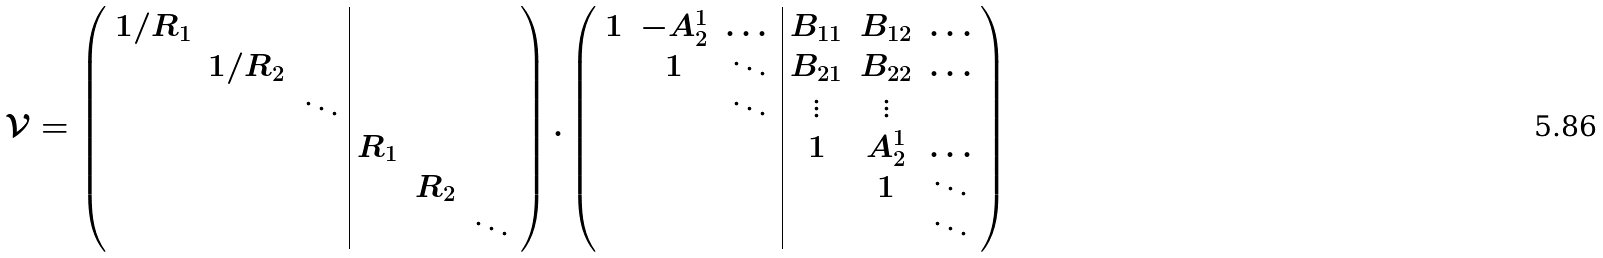Convert formula to latex. <formula><loc_0><loc_0><loc_500><loc_500>\mathcal { V } = \left ( \begin{array} { c c c | c c c } 1 / R _ { 1 } & & & & & \\ & 1 / R _ { 2 } & & & & \\ & & \ddots & & & \\ & & & R _ { 1 } & & \\ & & & & R _ { 2 } & \\ & & & & & \ddots \end{array} \right ) . \left ( \begin{array} { c c c | c c c } 1 & - A _ { 2 } ^ { 1 } & \dots & B _ { 1 1 } & B _ { 1 2 } & \dots \\ & 1 & \ddots & B _ { 2 1 } & B _ { 2 2 } & \dots \\ & & \ddots & \vdots & \vdots & \\ & & & 1 & A _ { 2 } ^ { 1 } & \dots \\ & & & & 1 & \ddots \\ & & & & & \ddots \\ \end{array} \right )</formula> 